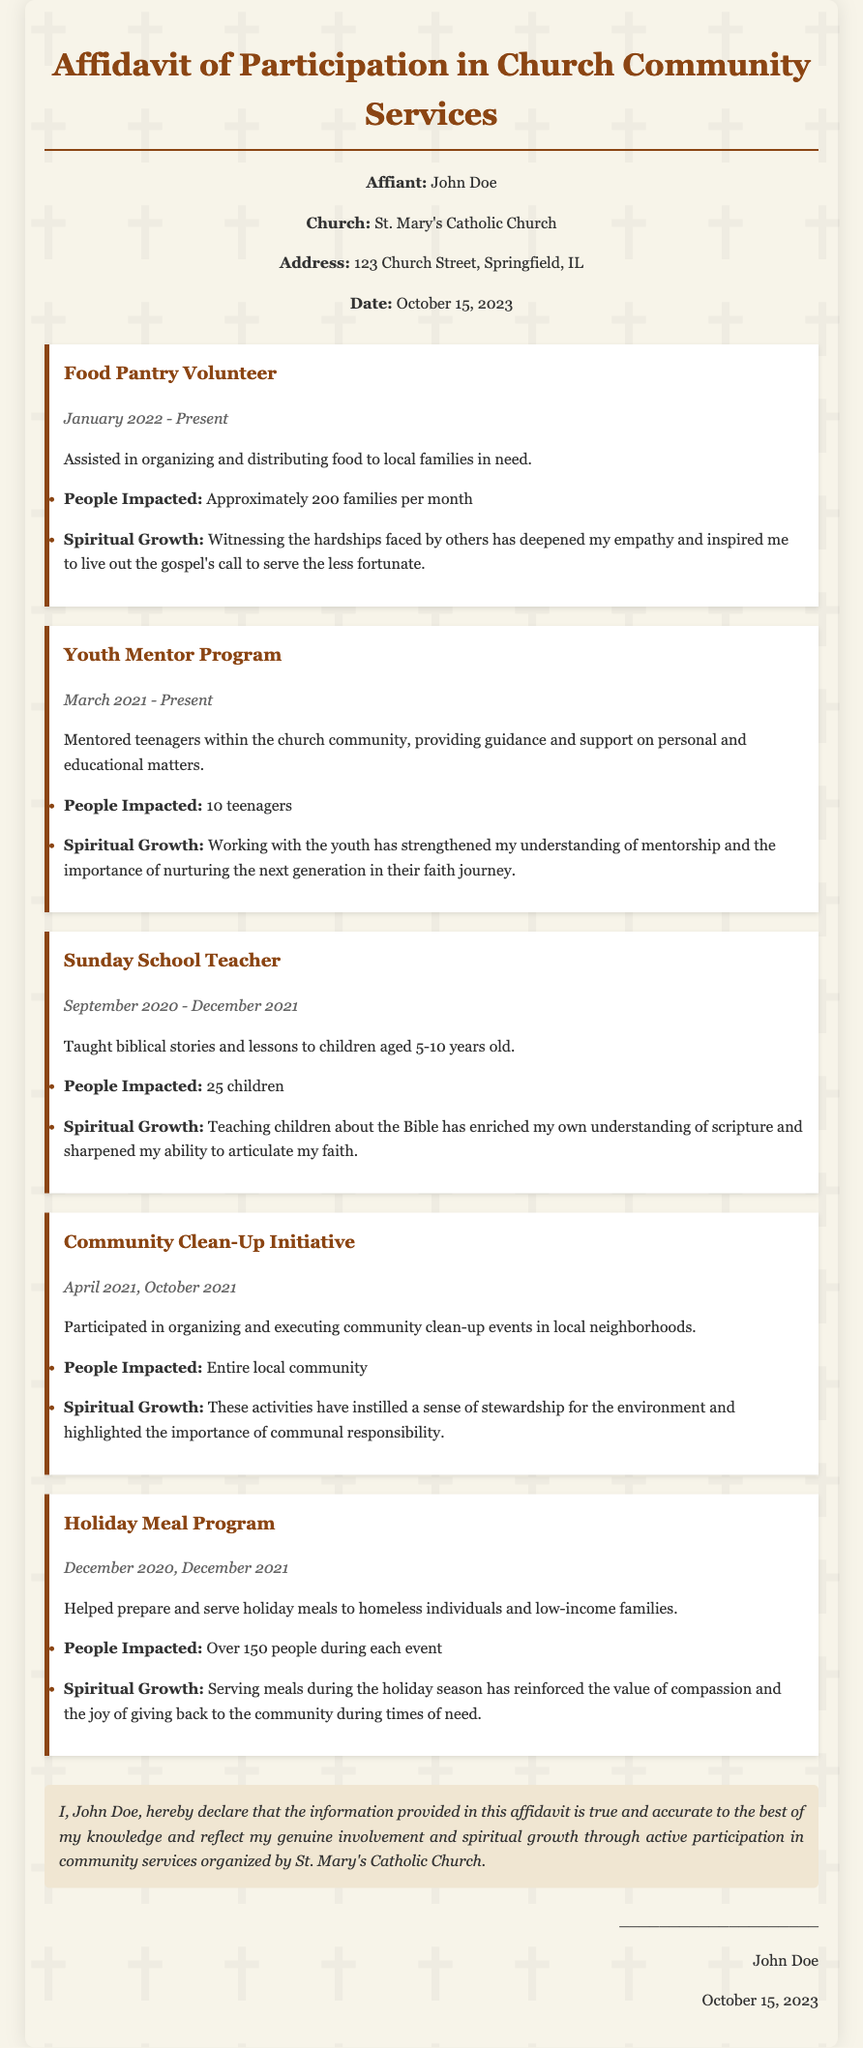What is the name of the affiant? The affiant is the person who makes the affidavit, in this case, it's clearly stated at the beginning of the document as John Doe.
Answer: John Doe What church is mentioned in the affidavit? The church is identified at the start of the document as St. Mary's Catholic Church.
Answer: St. Mary's Catholic Church What service did John Doe volunteer for from January 2022 to present? This service is detailed in the document, indicating John Doe's role in assisting with food distribution at the food pantry.
Answer: Food Pantry Volunteer How many teenagers did John Doe mentor in the Youth Mentor Program? The document provides specific information that John Doe mentored 10 teenagers.
Answer: 10 teenagers What was the spiritual growth experienced through teaching Sunday School? According to the document, teaching Sunday School enriched John Doe's own understanding of scripture.
Answer: Enriched understanding of scripture How many families did the Food Pantry impact each month? The affidavit states that approximately 200 families were impacted monthly through the food pantry activities.
Answer: Approximately 200 families In which months did the Holiday Meal Program events take place? The months are explicitly mentioned within the document, indicating that the events occurred in December 2020 and December 2021.
Answer: December 2020, December 2021 What was the impact of the Community Clean-Up Initiative? The affidavit clearly mentions the impact was felt by the entire local community.
Answer: Entire local community What is the date of the affidavit? The date can be found at the top of the document, stating when the affidavit was completed.
Answer: October 15, 2023 